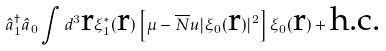Convert formula to latex. <formula><loc_0><loc_0><loc_500><loc_500>\hat { a } _ { 1 } ^ { \dagger } \hat { a } _ { 0 } \int d ^ { 3 } { \text {r} } \xi _ { 1 } ^ { \ast } ( { \text {r} } ) \left [ \mu - \overline { N } u | \xi _ { 0 } ( { \text {r} } ) | ^ { 2 } \right ] \xi _ { 0 } ( { \text {r} } ) + \text {h.c.}</formula> 